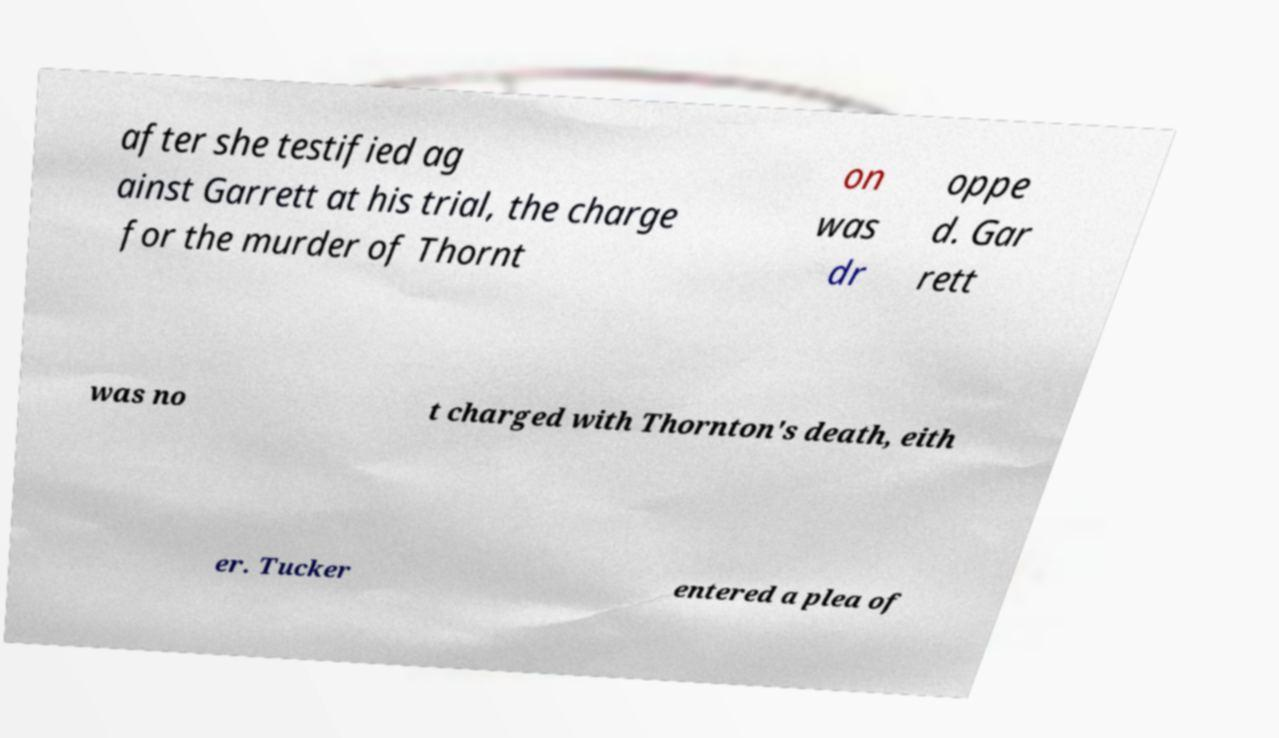For documentation purposes, I need the text within this image transcribed. Could you provide that? after she testified ag ainst Garrett at his trial, the charge for the murder of Thornt on was dr oppe d. Gar rett was no t charged with Thornton's death, eith er. Tucker entered a plea of 